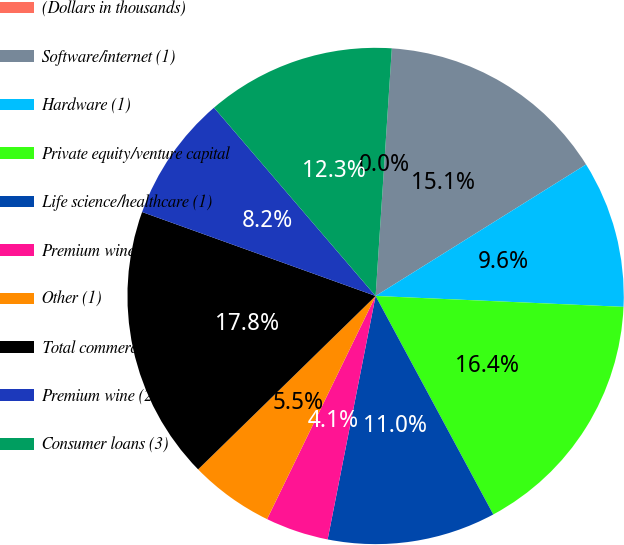<chart> <loc_0><loc_0><loc_500><loc_500><pie_chart><fcel>(Dollars in thousands)<fcel>Software/internet (1)<fcel>Hardware (1)<fcel>Private equity/venture capital<fcel>Life science/healthcare (1)<fcel>Premium wine<fcel>Other (1)<fcel>Total commercial loans<fcel>Premium wine (2)<fcel>Consumer loans (3)<nl><fcel>0.0%<fcel>15.07%<fcel>9.59%<fcel>16.44%<fcel>10.96%<fcel>4.11%<fcel>5.48%<fcel>17.81%<fcel>8.22%<fcel>12.33%<nl></chart> 